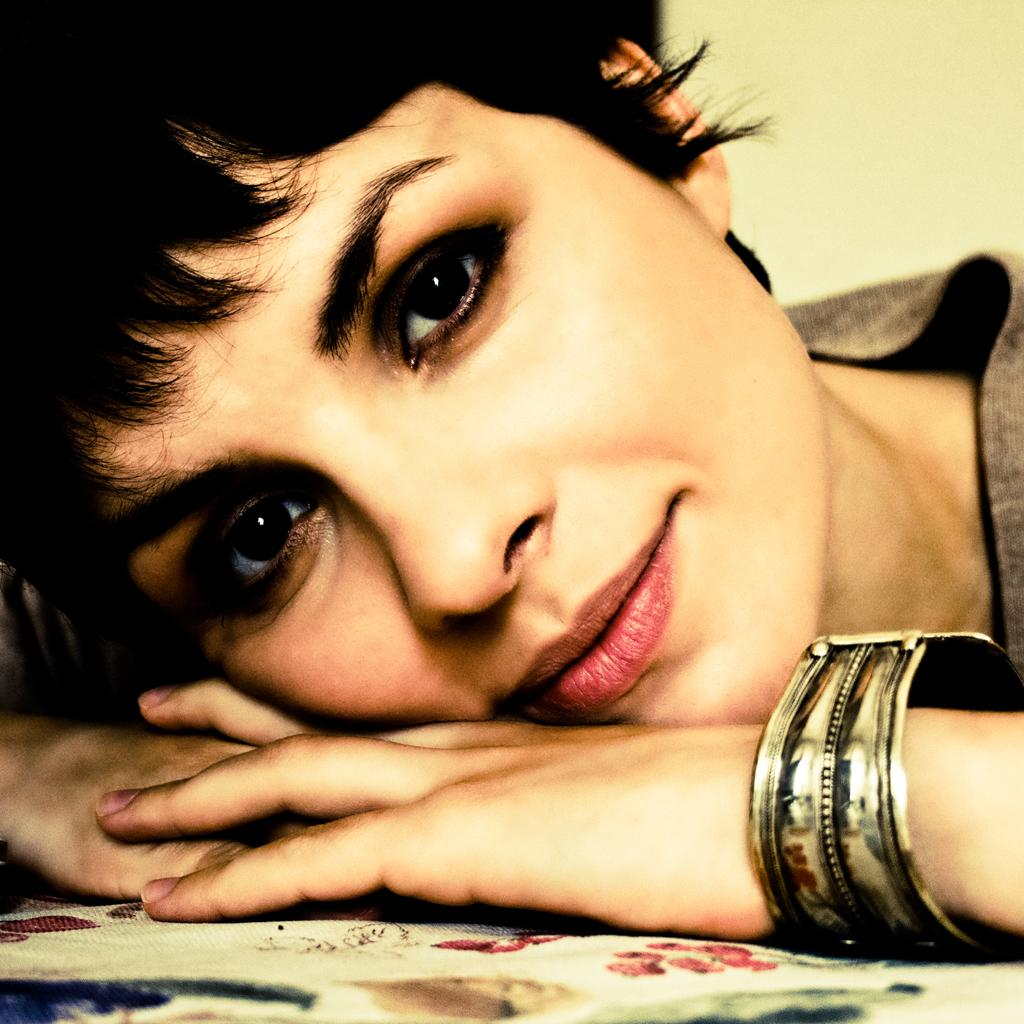What is the main subject of the image? There is a person in the image. What color is the background of the image? The background of the image is cream-colored. How many shows can be seen in the image? There are no shows present in the image. What is the height of the person in the image? The provided facts do not give information about the person's height, so it cannot be determined from the image. 